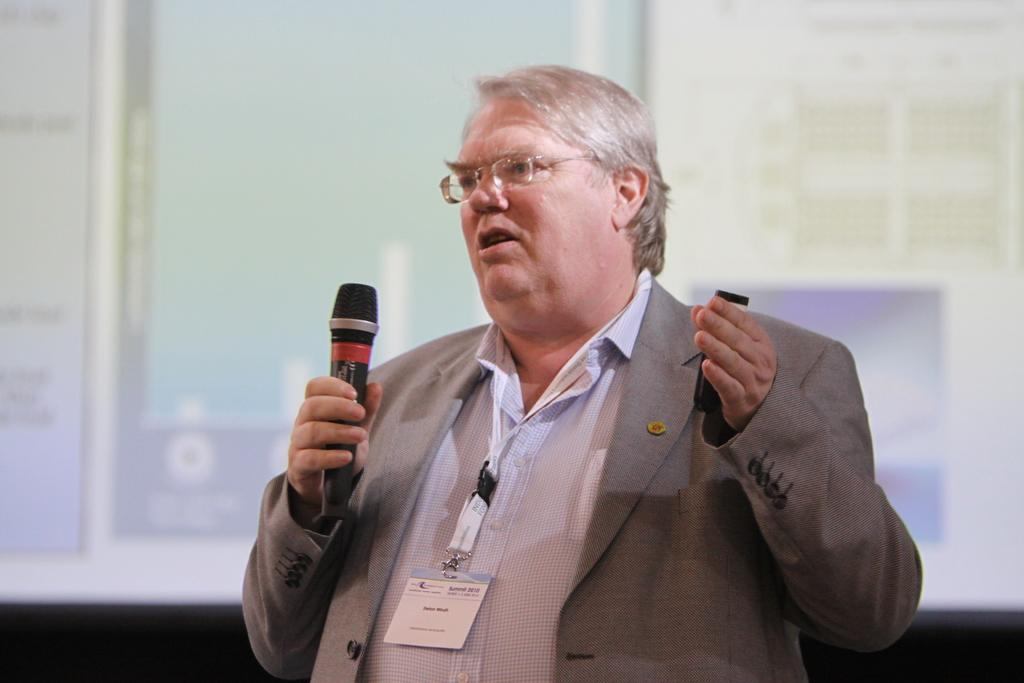Who is present in the image? There is a man in the image. What is the man doing in the image? The man is standing in the image. What object is the man holding in his hand? The man is holding a microphone in his hand. What type of cheese can be seen in the image? There is no cheese present in the image. 